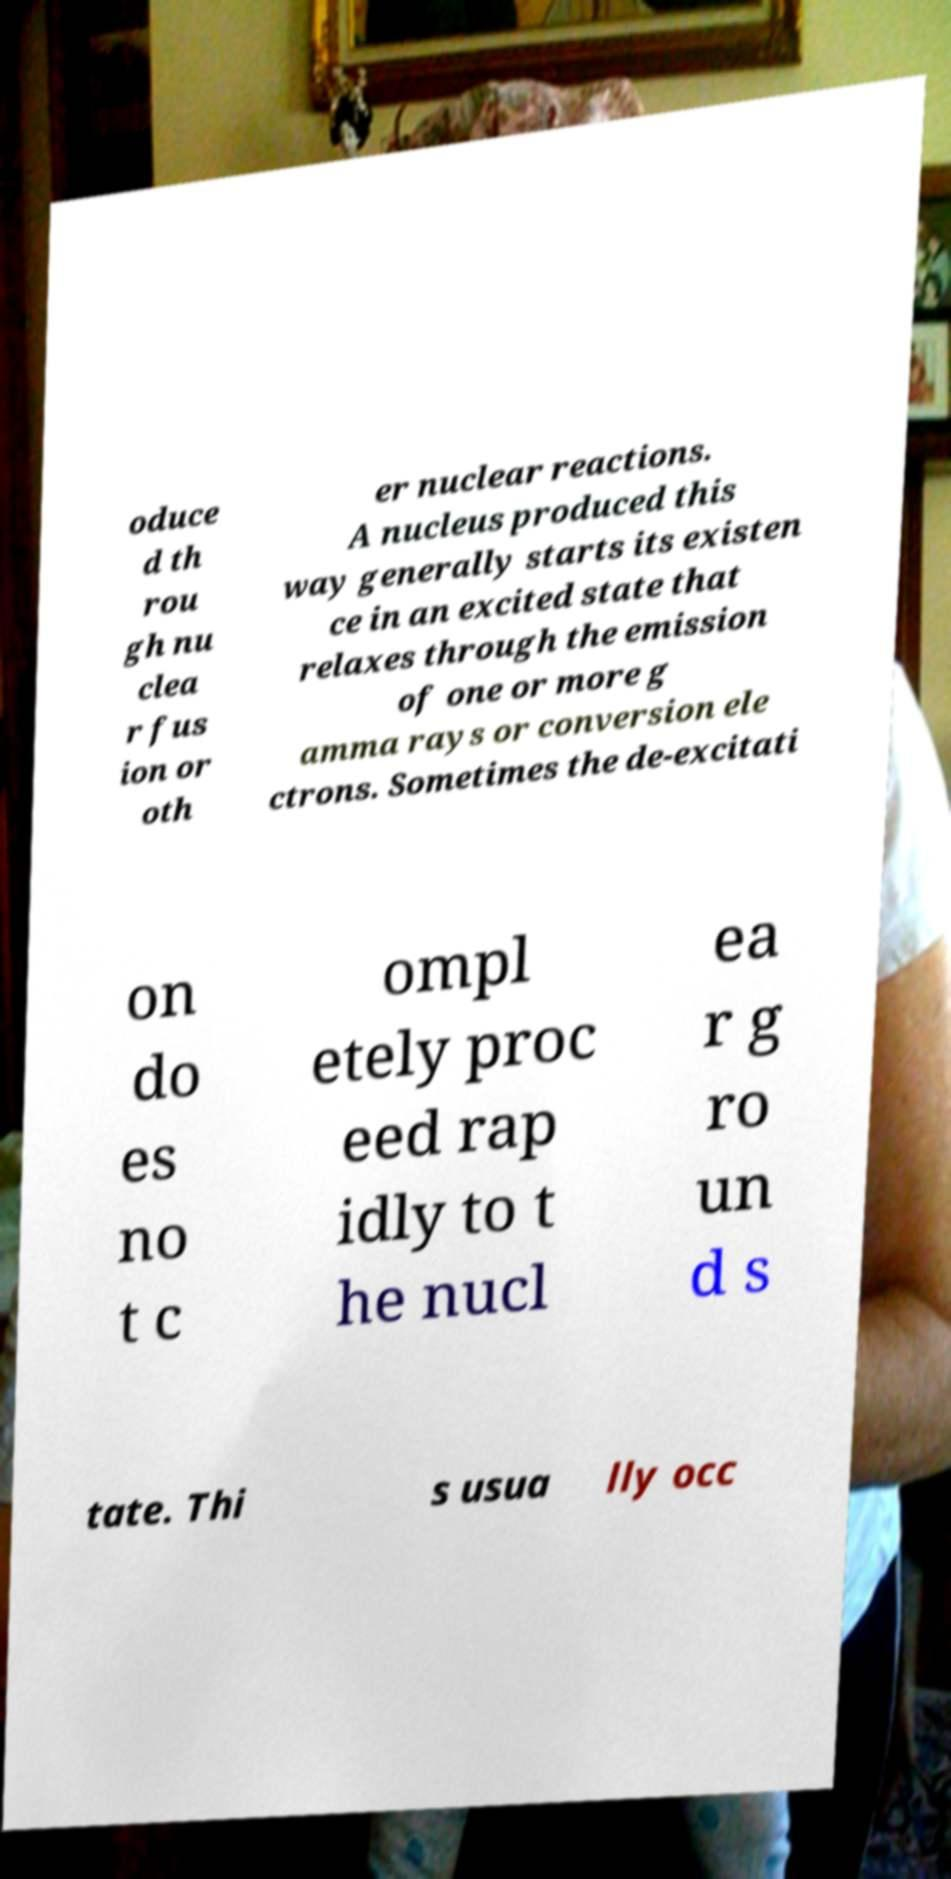Can you accurately transcribe the text from the provided image for me? oduce d th rou gh nu clea r fus ion or oth er nuclear reactions. A nucleus produced this way generally starts its existen ce in an excited state that relaxes through the emission of one or more g amma rays or conversion ele ctrons. Sometimes the de-excitati on do es no t c ompl etely proc eed rap idly to t he nucl ea r g ro un d s tate. Thi s usua lly occ 